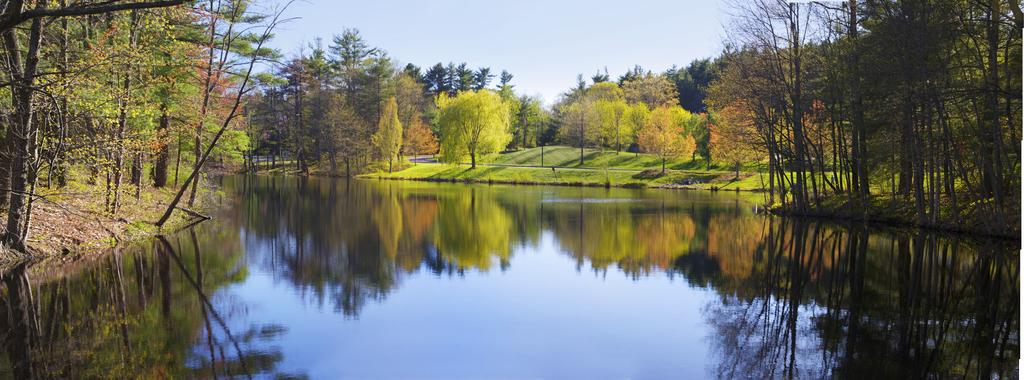What is present at the bottom of the image? There is water at the bottom of the image. What can be seen in the background of the image? There are trees and grass in the background of the image. What is visible at the top of the image? The sky is visible at the top of the image. Where are the dolls located in the image? There are no dolls present in the image. What is the temperature of the water in the image? The temperature of the water cannot be determined from the image alone. 